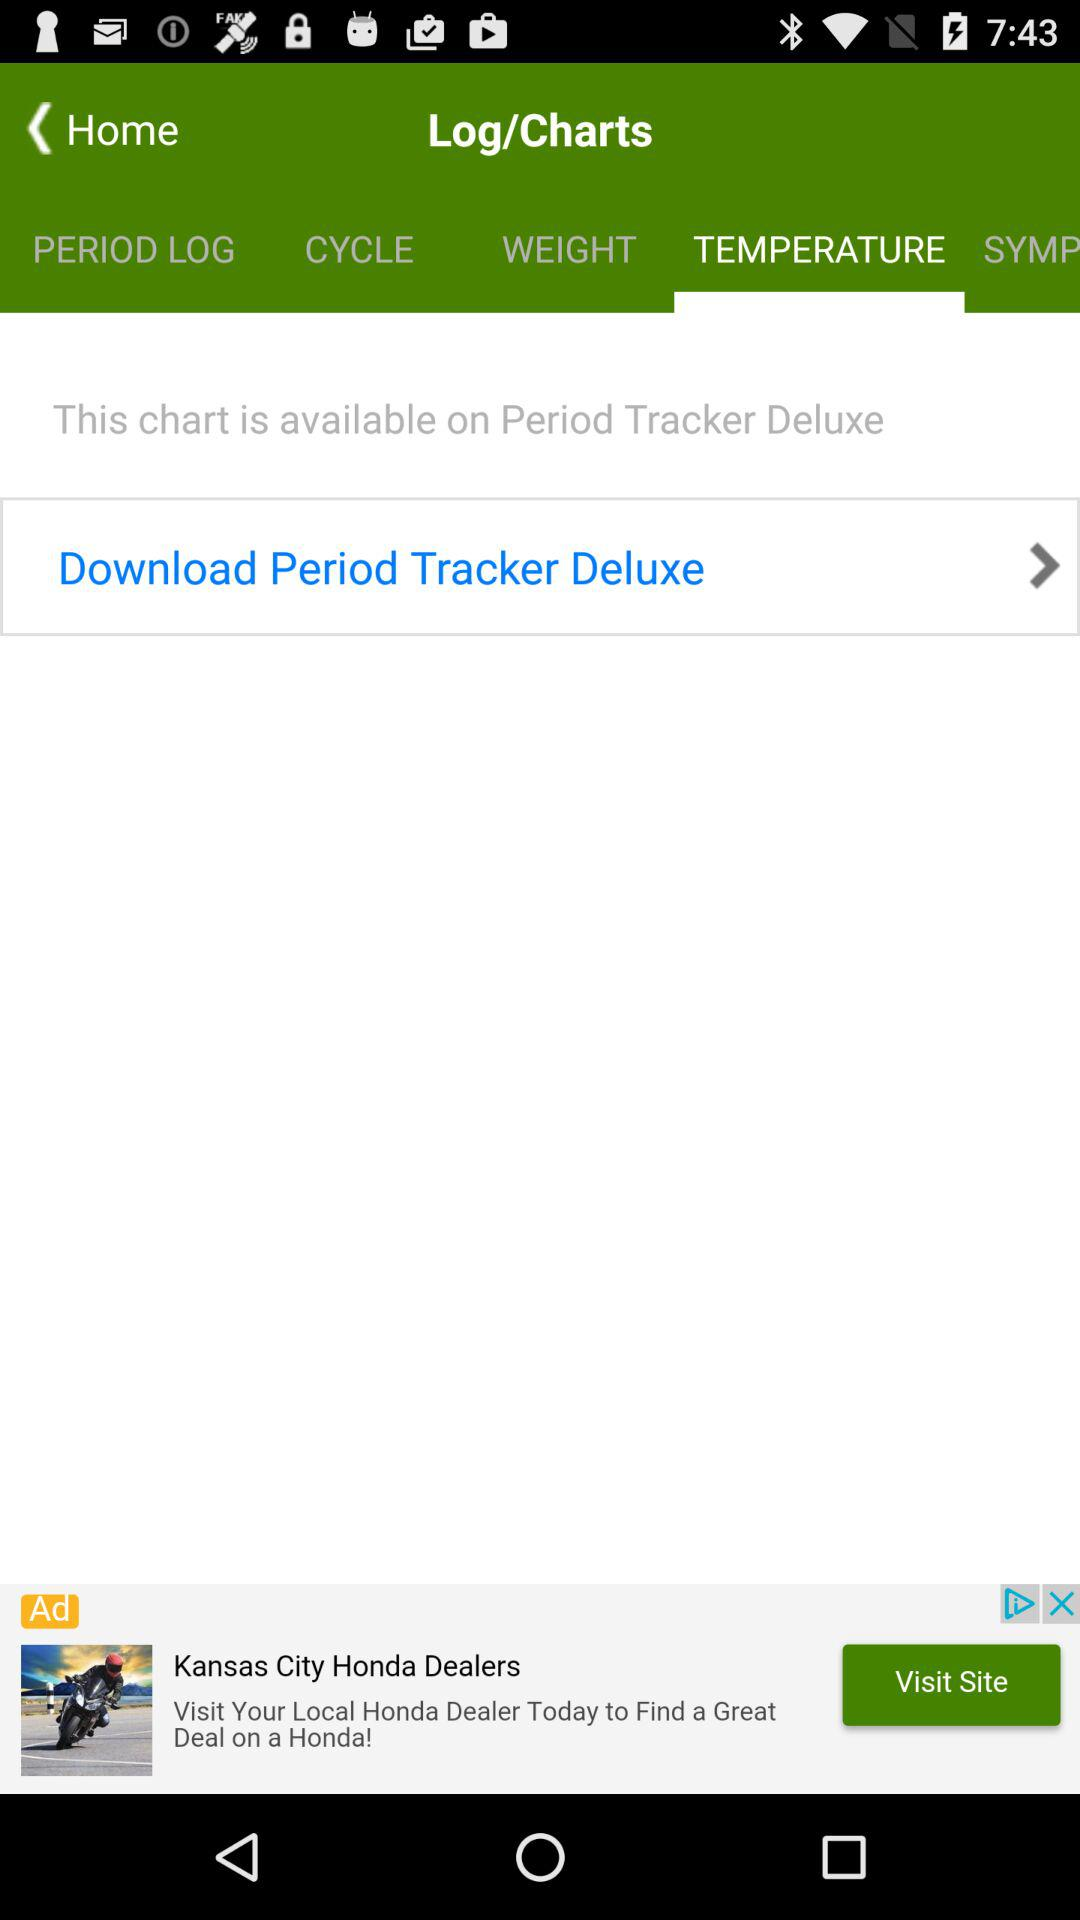How many items are in "CYCLE"?
When the provided information is insufficient, respond with <no answer>. <no answer> 